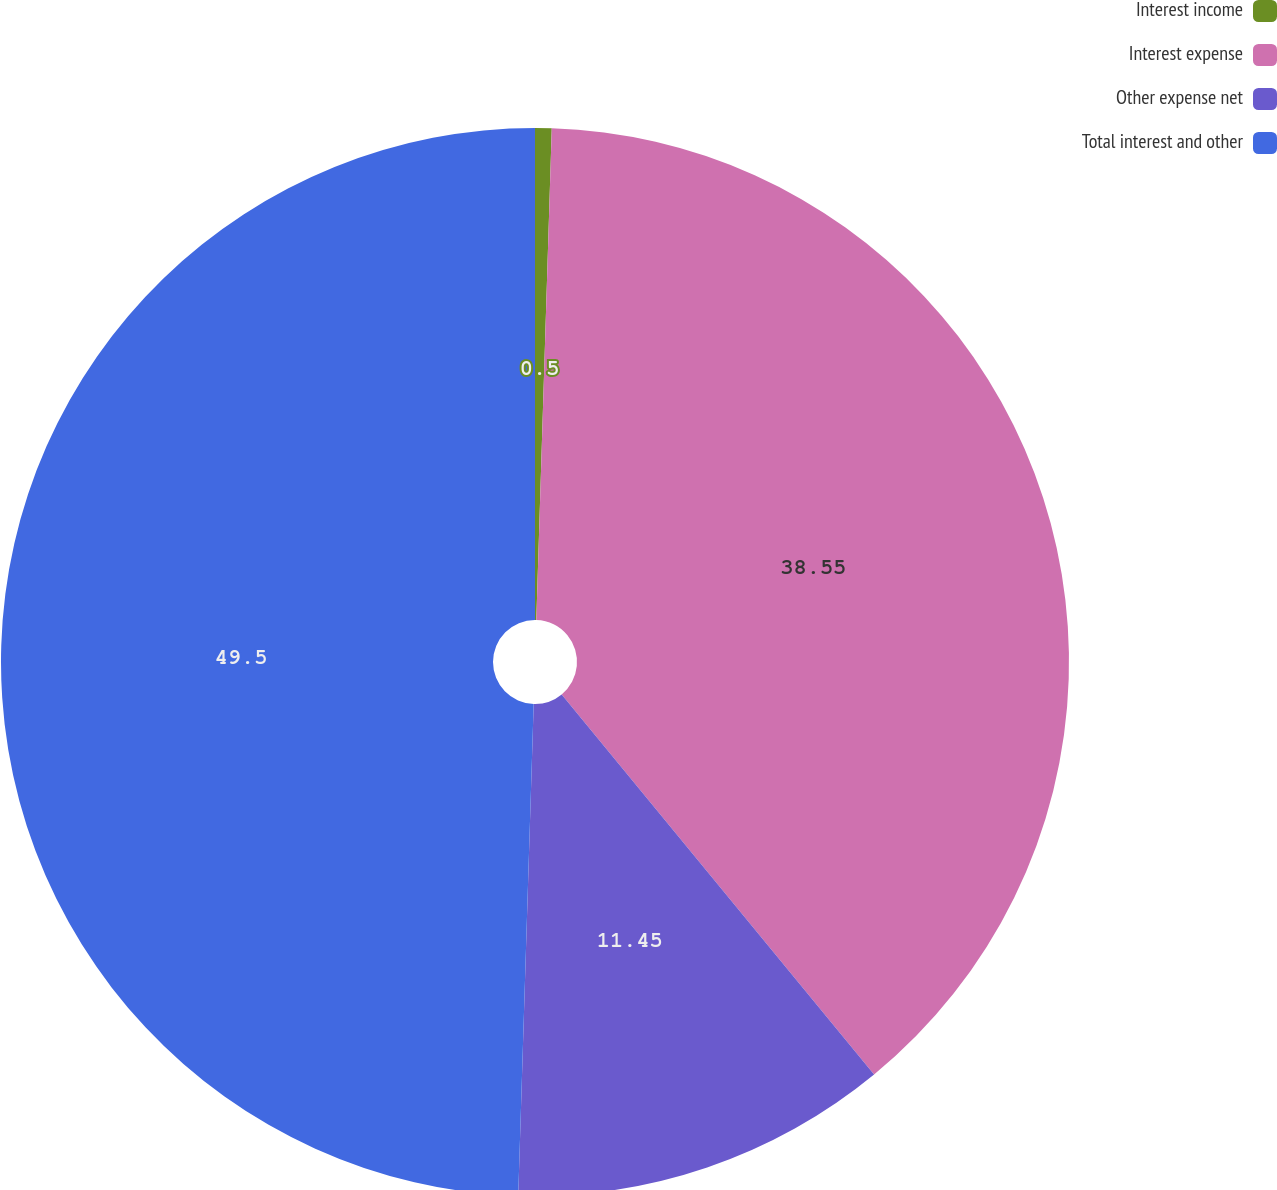Convert chart. <chart><loc_0><loc_0><loc_500><loc_500><pie_chart><fcel>Interest income<fcel>Interest expense<fcel>Other expense net<fcel>Total interest and other<nl><fcel>0.5%<fcel>38.55%<fcel>11.45%<fcel>49.5%<nl></chart> 